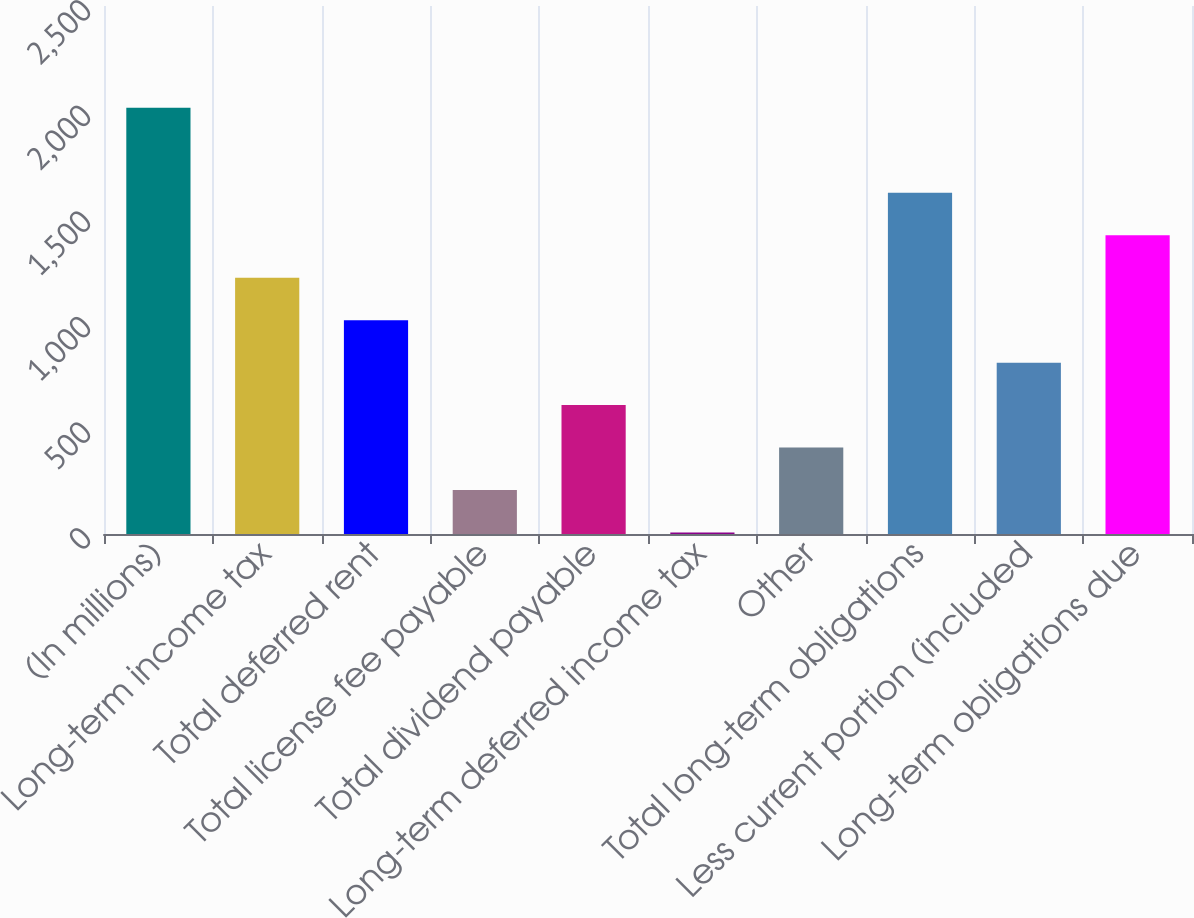<chart> <loc_0><loc_0><loc_500><loc_500><bar_chart><fcel>(In millions)<fcel>Long-term income tax<fcel>Total deferred rent<fcel>Total license fee payable<fcel>Total dividend payable<fcel>Long-term deferred income tax<fcel>Other<fcel>Total long-term obligations<fcel>Less current portion (included<fcel>Long-term obligations due<nl><fcel>2018<fcel>1213.6<fcel>1012.5<fcel>208.1<fcel>610.3<fcel>7<fcel>409.2<fcel>1615.8<fcel>811.4<fcel>1414.7<nl></chart> 